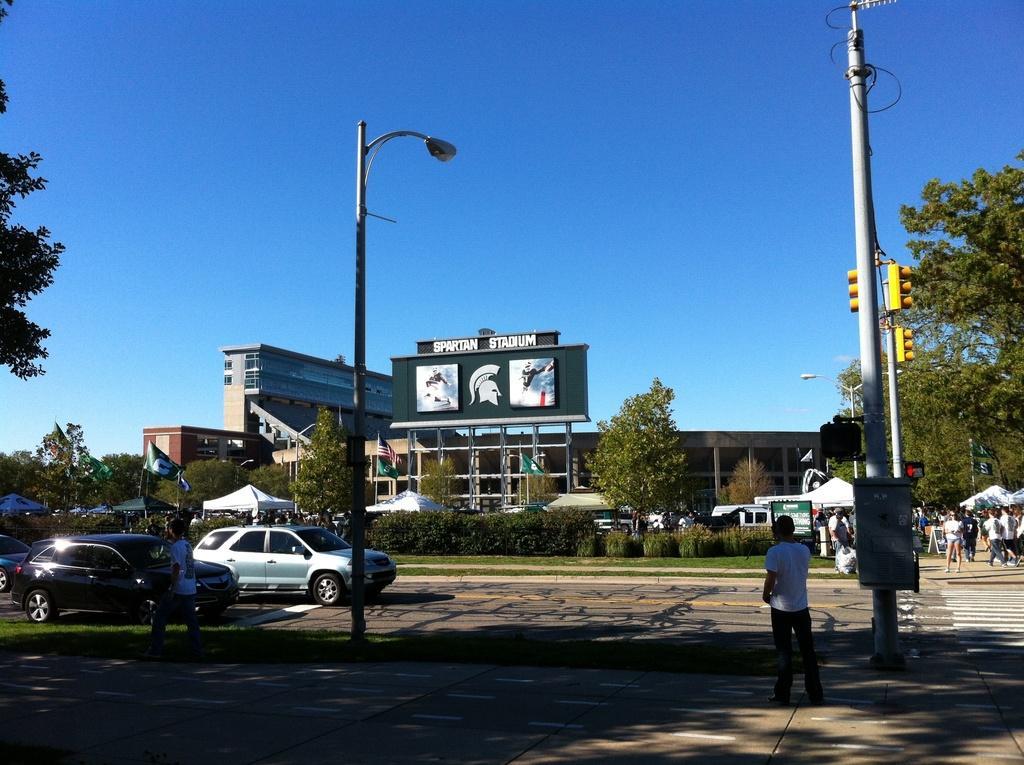Please provide a concise description of this image. In this picture there is a traffic pole on the right side of the image and there are cars on the left side of the image, there is a lamp pole in the center of the image and there are people, trees, posters, and buildings in the background area, it seems to be there are stalls in the background area. 